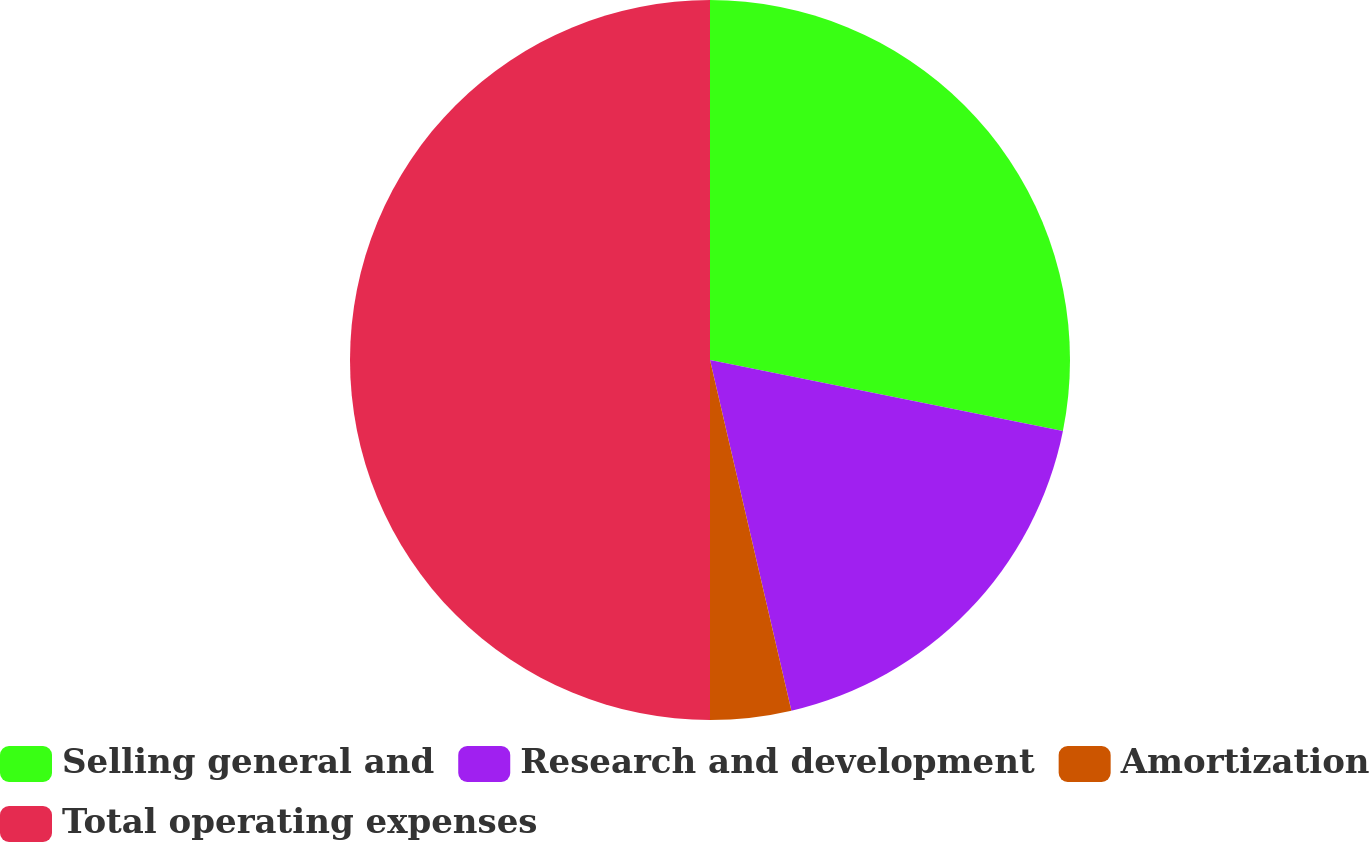Convert chart. <chart><loc_0><loc_0><loc_500><loc_500><pie_chart><fcel>Selling general and<fcel>Research and development<fcel>Amortization<fcel>Total operating expenses<nl><fcel>28.16%<fcel>18.21%<fcel>3.63%<fcel>50.0%<nl></chart> 